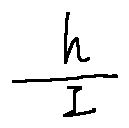<formula> <loc_0><loc_0><loc_500><loc_500>\frac { h } { I }</formula> 